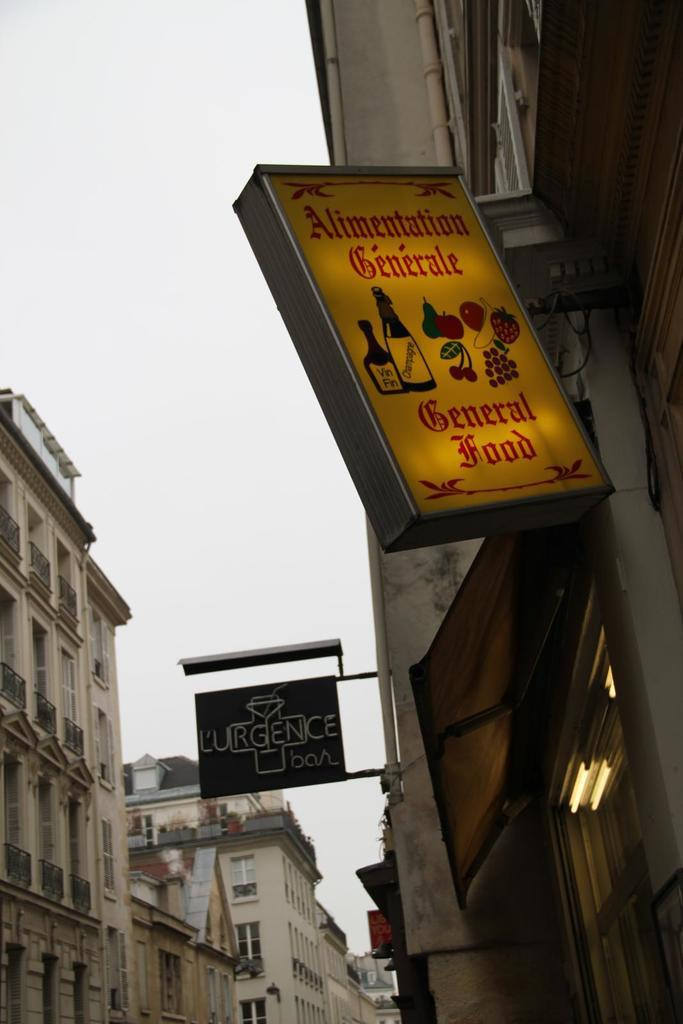<image>
Present a compact description of the photo's key features. A sign hanging off building lets you know that the business serves general food. 